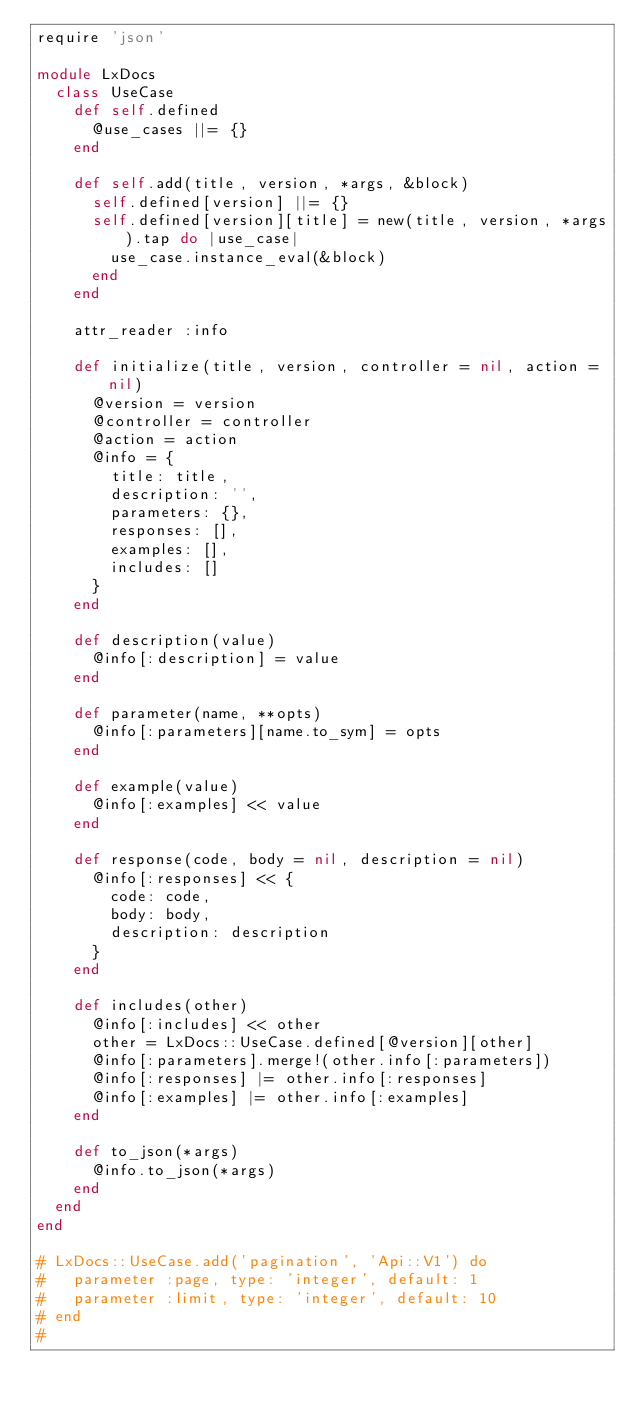<code> <loc_0><loc_0><loc_500><loc_500><_Ruby_>require 'json'

module LxDocs
  class UseCase
    def self.defined
      @use_cases ||= {}
    end

    def self.add(title, version, *args, &block)
      self.defined[version] ||= {}
      self.defined[version][title] = new(title, version, *args).tap do |use_case|
        use_case.instance_eval(&block)
      end
    end

    attr_reader :info

    def initialize(title, version, controller = nil, action = nil)
      @version = version
      @controller = controller
      @action = action
      @info = {
        title: title,
        description: '',
        parameters: {},
        responses: [],
        examples: [],
        includes: []
      }
    end

    def description(value)
      @info[:description] = value
    end

    def parameter(name, **opts)
      @info[:parameters][name.to_sym] = opts
    end

    def example(value)
      @info[:examples] << value
    end

    def response(code, body = nil, description = nil)
      @info[:responses] << {
        code: code,
        body: body,
        description: description
      }
    end

    def includes(other)
      @info[:includes] << other
      other = LxDocs::UseCase.defined[@version][other]
      @info[:parameters].merge!(other.info[:parameters])
      @info[:responses] |= other.info[:responses]
      @info[:examples] |= other.info[:examples]
    end

    def to_json(*args)
      @info.to_json(*args)
    end
  end
end

# LxDocs::UseCase.add('pagination', 'Api::V1') do
#   parameter :page, type: 'integer', default: 1
#   parameter :limit, type: 'integer', default: 10
# end
#</code> 